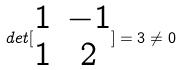<formula> <loc_0><loc_0><loc_500><loc_500>d e t [ \begin{matrix} 1 & - 1 \\ 1 & 2 \end{matrix} ] = 3 \ne 0</formula> 